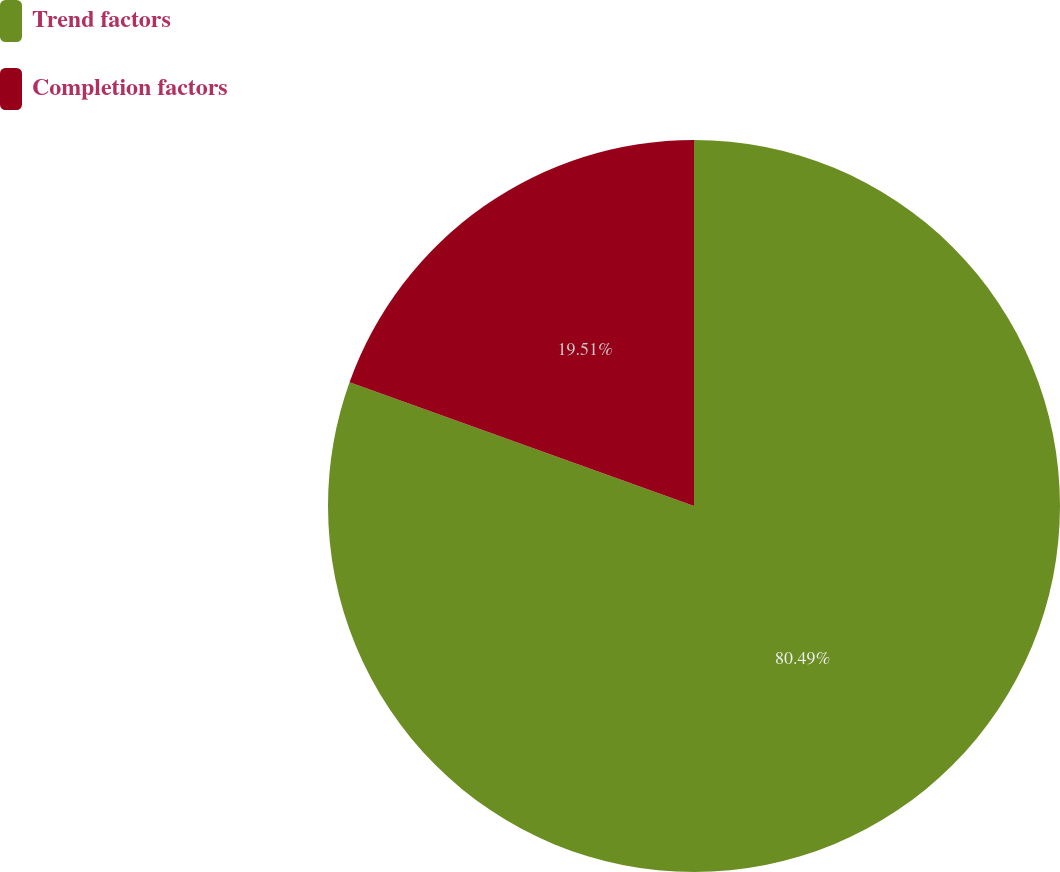Convert chart to OTSL. <chart><loc_0><loc_0><loc_500><loc_500><pie_chart><fcel>Trend factors<fcel>Completion factors<nl><fcel>80.49%<fcel>19.51%<nl></chart> 